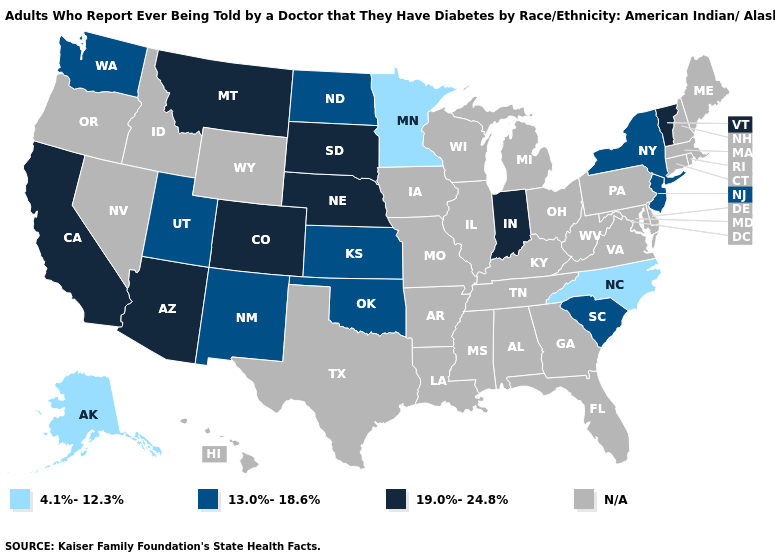Which states hav the highest value in the Northeast?
Concise answer only. Vermont. Name the states that have a value in the range 13.0%-18.6%?
Write a very short answer. Kansas, New Jersey, New Mexico, New York, North Dakota, Oklahoma, South Carolina, Utah, Washington. Does the map have missing data?
Quick response, please. Yes. Among the states that border Oklahoma , which have the highest value?
Answer briefly. Colorado. Does South Dakota have the highest value in the USA?
Short answer required. Yes. What is the value of Nebraska?
Concise answer only. 19.0%-24.8%. Name the states that have a value in the range N/A?
Keep it brief. Alabama, Arkansas, Connecticut, Delaware, Florida, Georgia, Hawaii, Idaho, Illinois, Iowa, Kentucky, Louisiana, Maine, Maryland, Massachusetts, Michigan, Mississippi, Missouri, Nevada, New Hampshire, Ohio, Oregon, Pennsylvania, Rhode Island, Tennessee, Texas, Virginia, West Virginia, Wisconsin, Wyoming. What is the value of South Carolina?
Quick response, please. 13.0%-18.6%. What is the value of Virginia?
Short answer required. N/A. How many symbols are there in the legend?
Keep it brief. 4. How many symbols are there in the legend?
Give a very brief answer. 4. Name the states that have a value in the range 19.0%-24.8%?
Be succinct. Arizona, California, Colorado, Indiana, Montana, Nebraska, South Dakota, Vermont. What is the value of New Hampshire?
Give a very brief answer. N/A. 